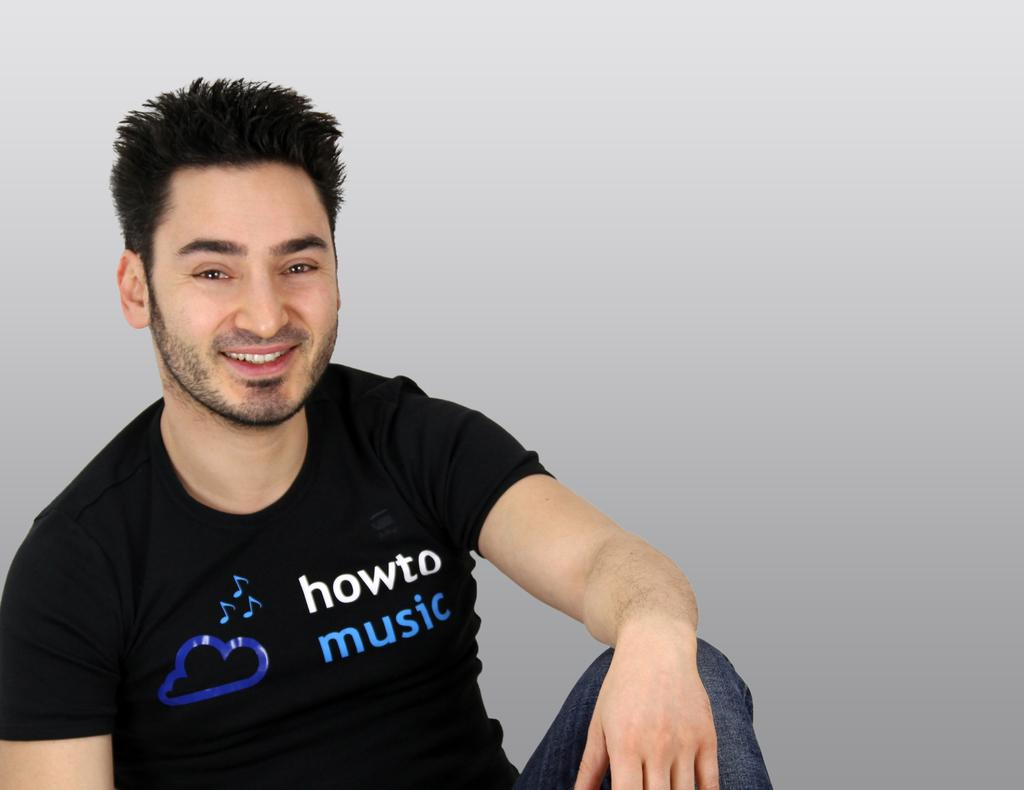What is the main subject of the image? There is a person in the image. What is the person wearing? The person is wearing a black T-shirt. What is the person doing in the image? The person is sitting and posing for a photograph. What is the person's facial expression? The person is smiling. What can be seen in the background of the image? There is a wall in the background of the image. What type of plantation can be seen in the image? There is no plantation present in the image. What color is the orange in the image? There is no orange present in the image. 